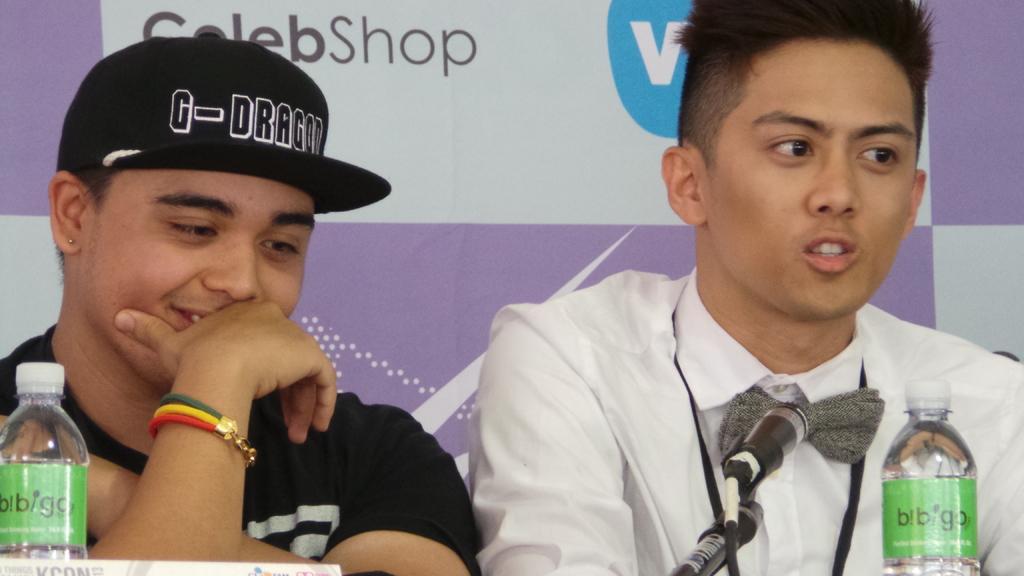Can you describe this image briefly? This man wore black t-shirt and cap. This man wore white shirt. In-front of this person there is a bottle and mic. 